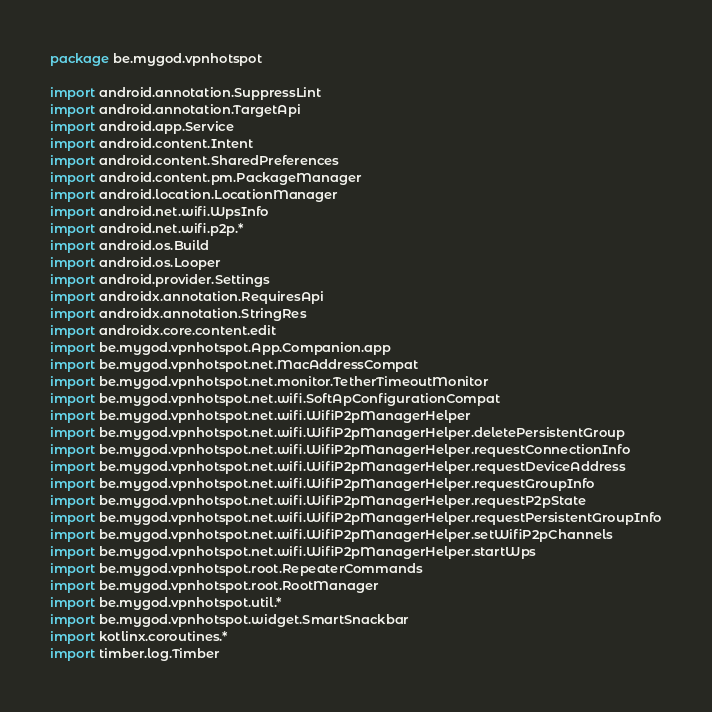<code> <loc_0><loc_0><loc_500><loc_500><_Kotlin_>package be.mygod.vpnhotspot

import android.annotation.SuppressLint
import android.annotation.TargetApi
import android.app.Service
import android.content.Intent
import android.content.SharedPreferences
import android.content.pm.PackageManager
import android.location.LocationManager
import android.net.wifi.WpsInfo
import android.net.wifi.p2p.*
import android.os.Build
import android.os.Looper
import android.provider.Settings
import androidx.annotation.RequiresApi
import androidx.annotation.StringRes
import androidx.core.content.edit
import be.mygod.vpnhotspot.App.Companion.app
import be.mygod.vpnhotspot.net.MacAddressCompat
import be.mygod.vpnhotspot.net.monitor.TetherTimeoutMonitor
import be.mygod.vpnhotspot.net.wifi.SoftApConfigurationCompat
import be.mygod.vpnhotspot.net.wifi.WifiP2pManagerHelper
import be.mygod.vpnhotspot.net.wifi.WifiP2pManagerHelper.deletePersistentGroup
import be.mygod.vpnhotspot.net.wifi.WifiP2pManagerHelper.requestConnectionInfo
import be.mygod.vpnhotspot.net.wifi.WifiP2pManagerHelper.requestDeviceAddress
import be.mygod.vpnhotspot.net.wifi.WifiP2pManagerHelper.requestGroupInfo
import be.mygod.vpnhotspot.net.wifi.WifiP2pManagerHelper.requestP2pState
import be.mygod.vpnhotspot.net.wifi.WifiP2pManagerHelper.requestPersistentGroupInfo
import be.mygod.vpnhotspot.net.wifi.WifiP2pManagerHelper.setWifiP2pChannels
import be.mygod.vpnhotspot.net.wifi.WifiP2pManagerHelper.startWps
import be.mygod.vpnhotspot.root.RepeaterCommands
import be.mygod.vpnhotspot.root.RootManager
import be.mygod.vpnhotspot.util.*
import be.mygod.vpnhotspot.widget.SmartSnackbar
import kotlinx.coroutines.*
import timber.log.Timber</code> 